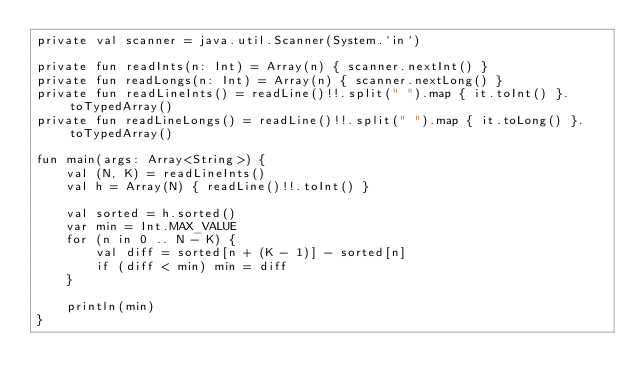Convert code to text. <code><loc_0><loc_0><loc_500><loc_500><_Kotlin_>private val scanner = java.util.Scanner(System.`in`)

private fun readInts(n: Int) = Array(n) { scanner.nextInt() }
private fun readLongs(n: Int) = Array(n) { scanner.nextLong() }
private fun readLineInts() = readLine()!!.split(" ").map { it.toInt() }.toTypedArray()
private fun readLineLongs() = readLine()!!.split(" ").map { it.toLong() }.toTypedArray()

fun main(args: Array<String>) {
    val (N, K) = readLineInts()
    val h = Array(N) { readLine()!!.toInt() }

    val sorted = h.sorted()
    var min = Int.MAX_VALUE
    for (n in 0 .. N - K) {
        val diff = sorted[n + (K - 1)] - sorted[n]
        if (diff < min) min = diff
    }

    println(min)
}</code> 